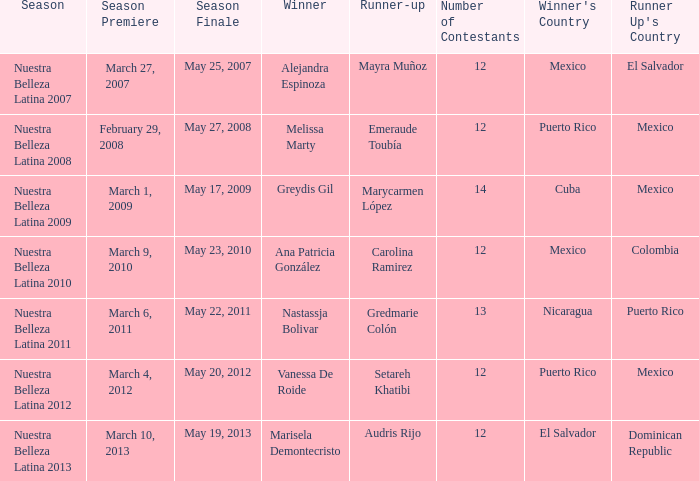How many contestants were there in a season where alejandra espinoza won? 1.0. 